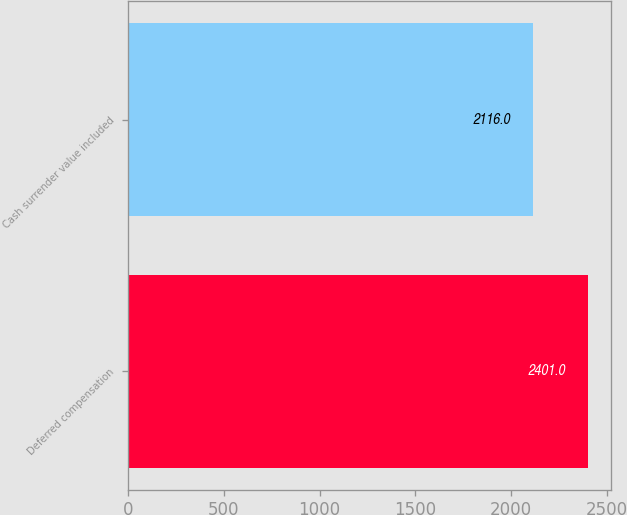Convert chart to OTSL. <chart><loc_0><loc_0><loc_500><loc_500><bar_chart><fcel>Deferred compensation<fcel>Cash surrender value included<nl><fcel>2401<fcel>2116<nl></chart> 